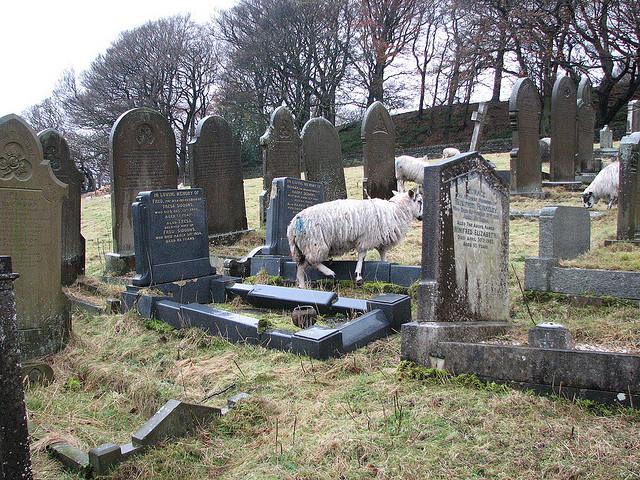What animals are shown?
Short answer required. Sheep. How many animals are in the picture?
Quick response, please. 4. What are the stone objects?
Write a very short answer. Headstones. 